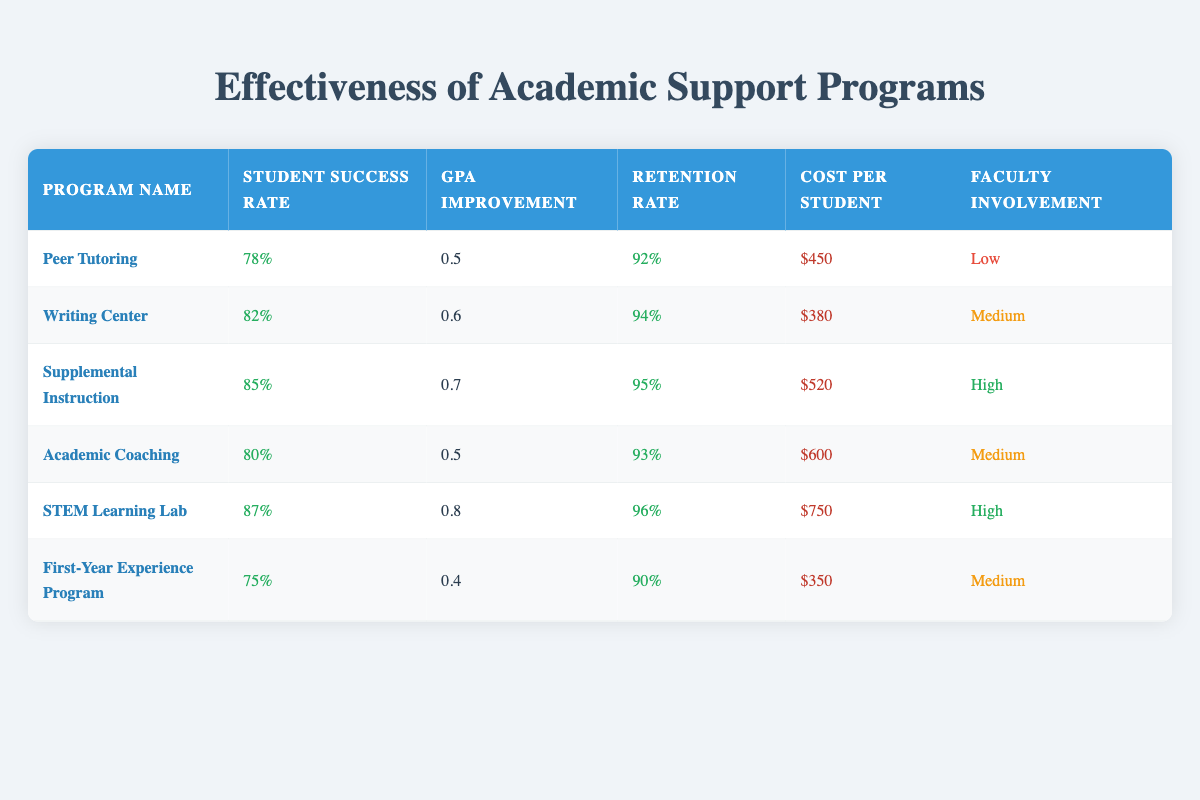What is the student success rate of the STEM Learning Lab? The student success rate for each program is explicitly listed in the table, and for the STEM Learning Lab, it is stated as 87%.
Answer: 87% Which program has the highest retention rate? The retention rate is provided for each program, and by comparing the rates, we see that the STEM Learning Lab has the highest retention rate at 96%.
Answer: STEM Learning Lab What is the average GPA improvement across all the programs? To find the average GPA improvement, we sum the improvements (0.5 + 0.6 + 0.7 + 0.5 + 0.8 + 0.4 = 3.5) and divide by the number of programs (6). Thus, the average is 3.5/6 = 0.5833, rounded to two decimal places is 0.58.
Answer: 0.58 Is the cost per student for the Writing Center less than the cost for Academic Coaching? According to the table, the cost per student for the Writing Center is $380, while the cost for Academic Coaching is $600. Since $380 is less than $600, the statement is true.
Answer: Yes Which program has the lowest student success rate and what is its rate? By examining the student success rates in the table, the First-Year Experience Program has the lowest rate at 75%.
Answer: 75% 